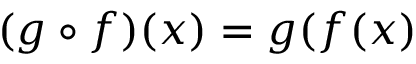<formula> <loc_0><loc_0><loc_500><loc_500>( g \circ f ) ( x ) = g ( f ( x )</formula> 